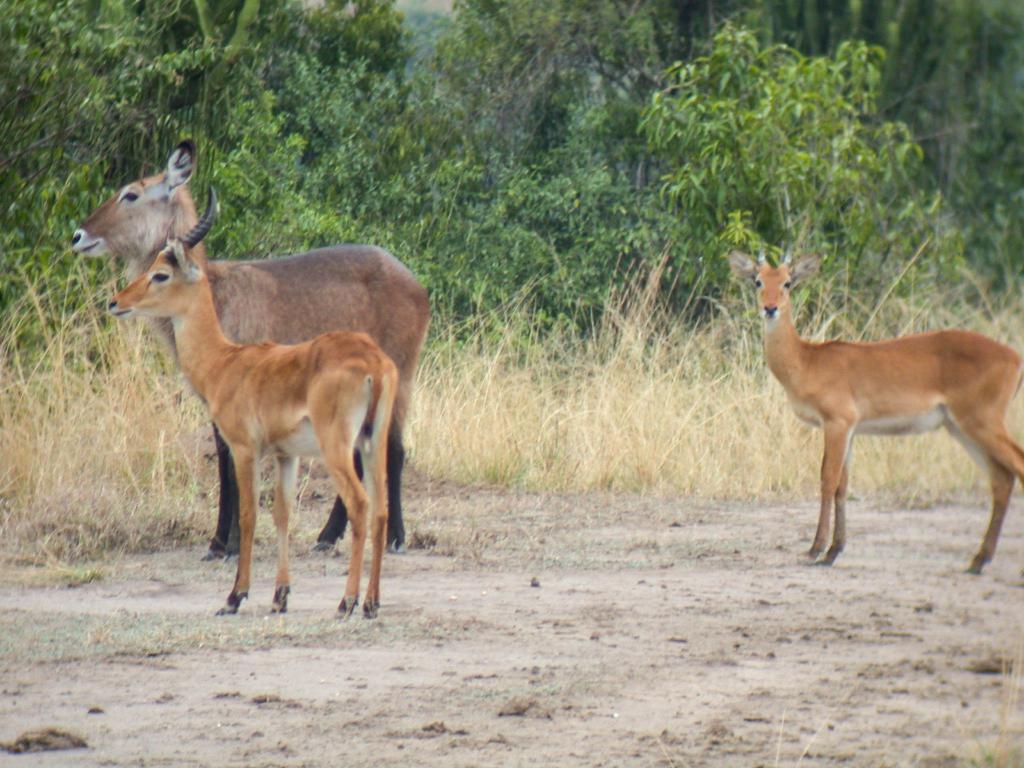Can you describe this image briefly? In this image there are three deers standing on the ground. In the background there are trees. At the bottom there is sand. Beside the sand there is grass. 